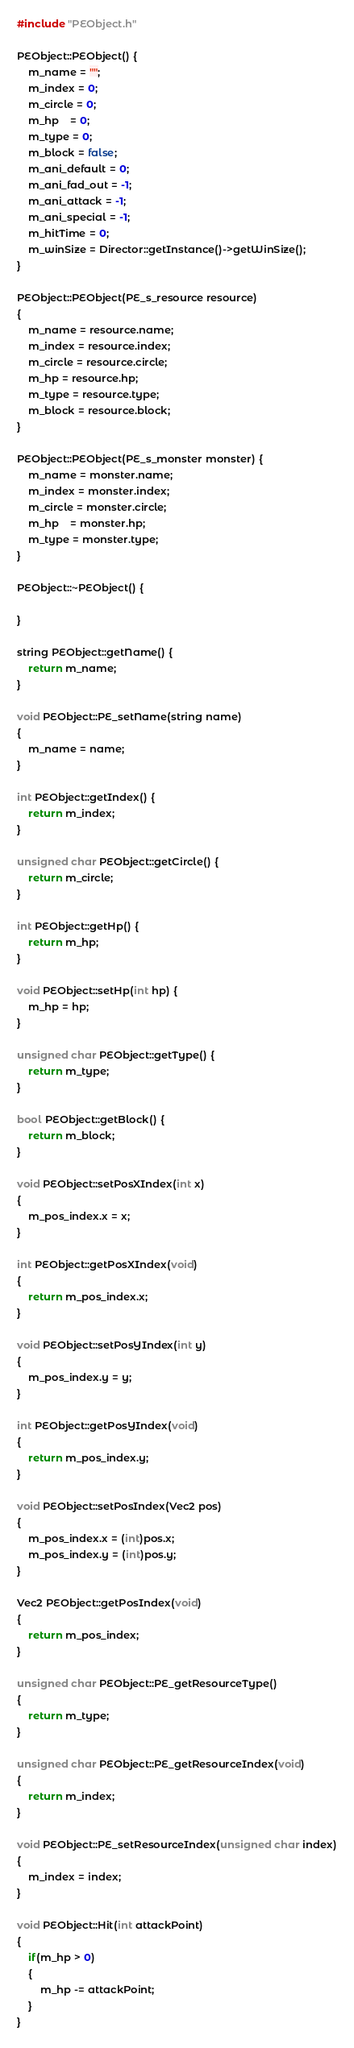Convert code to text. <code><loc_0><loc_0><loc_500><loc_500><_C++_>#include "PEObject.h"

PEObject::PEObject() {
	m_name = "";
	m_index = 0;
	m_circle = 0;
	m_hp	= 0;
	m_type = 0;
	m_block = false;
	m_ani_default = 0;
	m_ani_fad_out = -1;
	m_ani_attack = -1;
	m_ani_special = -1;
	m_hitTime = 0;
	m_winSize = Director::getInstance()->getWinSize();
}

PEObject::PEObject(PE_s_resource resource)
{
	m_name = resource.name;
	m_index = resource.index;
	m_circle = resource.circle;
	m_hp = resource.hp;
	m_type = resource.type;
	m_block = resource.block;
}

PEObject::PEObject(PE_s_monster monster) {
	m_name = monster.name;
	m_index = monster.index;
	m_circle = monster.circle;
	m_hp	= monster.hp;
	m_type = monster.type;
}

PEObject::~PEObject() {

}

string PEObject::getName() {
	return m_name;
}

void PEObject::PE_setName(string name)
{
	m_name = name;
}

int PEObject::getIndex() {
	return m_index;
}

unsigned char PEObject::getCircle() {
	return m_circle;
}

int PEObject::getHp() {
	return m_hp;
}

void PEObject::setHp(int hp) {
	m_hp = hp;
}

unsigned char PEObject::getType() {
	return m_type;
}

bool PEObject::getBlock() {
	return m_block;
}

void PEObject::setPosXIndex(int x)
{
	m_pos_index.x = x;
}

int PEObject::getPosXIndex(void)
{
	return m_pos_index.x;
}

void PEObject::setPosYIndex(int y)
{
	m_pos_index.y = y;
}

int PEObject::getPosYIndex(void)
{
	return m_pos_index.y;
}

void PEObject::setPosIndex(Vec2 pos)
{
	m_pos_index.x = (int)pos.x;
	m_pos_index.y = (int)pos.y;
}

Vec2 PEObject::getPosIndex(void)
{
	return m_pos_index;
}

unsigned char PEObject::PE_getResourceType()
{
	return m_type;
}

unsigned char PEObject::PE_getResourceIndex(void)
{
	return m_index;
}

void PEObject::PE_setResourceIndex(unsigned char index)
{
	m_index = index;
}

void PEObject::Hit(int attackPoint)
{
	if(m_hp > 0)
	{
		m_hp -= attackPoint;
	}
}
</code> 